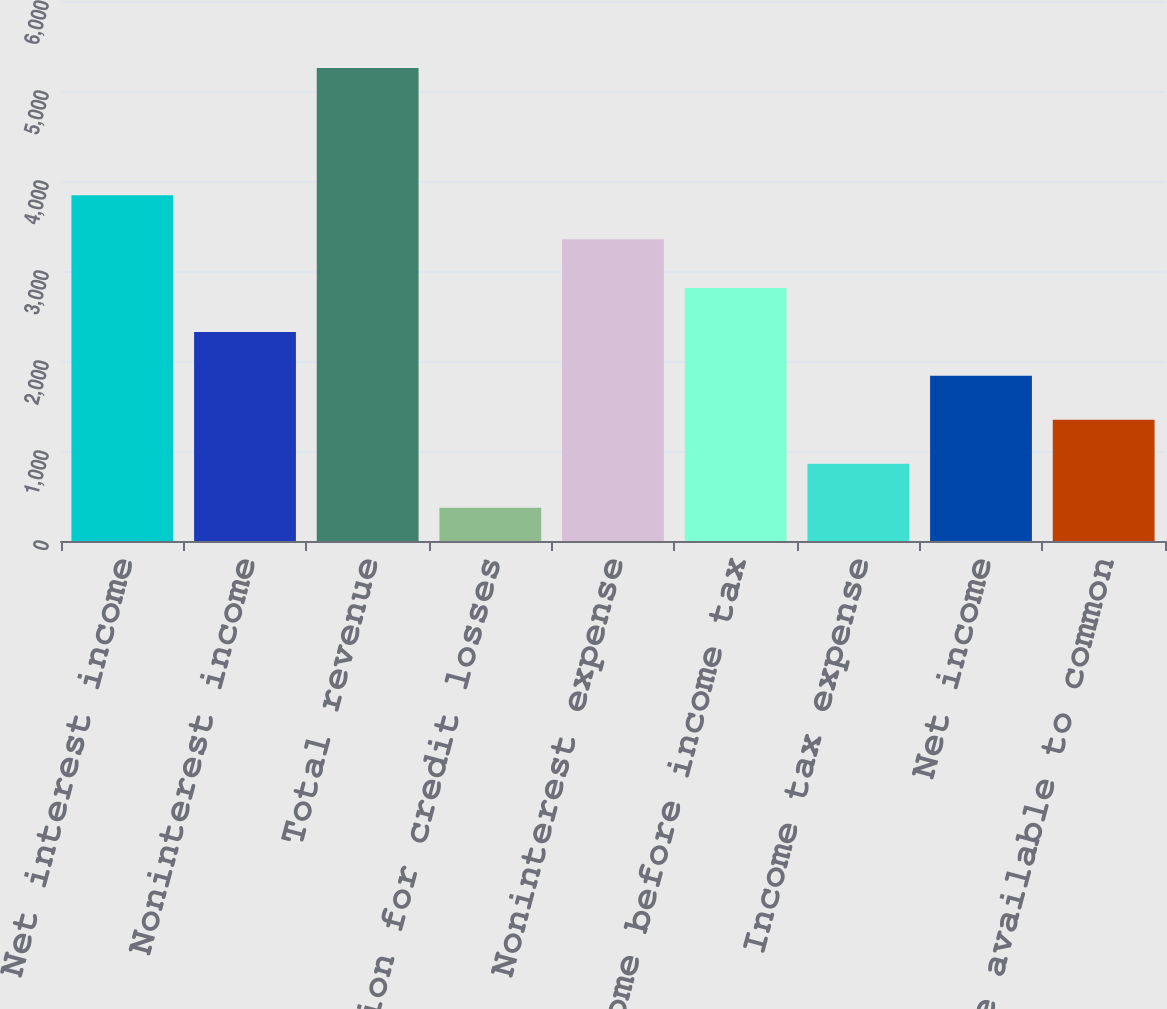Convert chart. <chart><loc_0><loc_0><loc_500><loc_500><bar_chart><fcel>Net interest income<fcel>Noninterest income<fcel>Total revenue<fcel>Provision for credit losses<fcel>Noninterest expense<fcel>Income before income tax<fcel>Income tax expense<fcel>Net income<fcel>Net income available to common<nl><fcel>3840.6<fcel>2323.4<fcel>5255<fcel>369<fcel>3352<fcel>2812<fcel>857.6<fcel>1834.8<fcel>1346.2<nl></chart> 